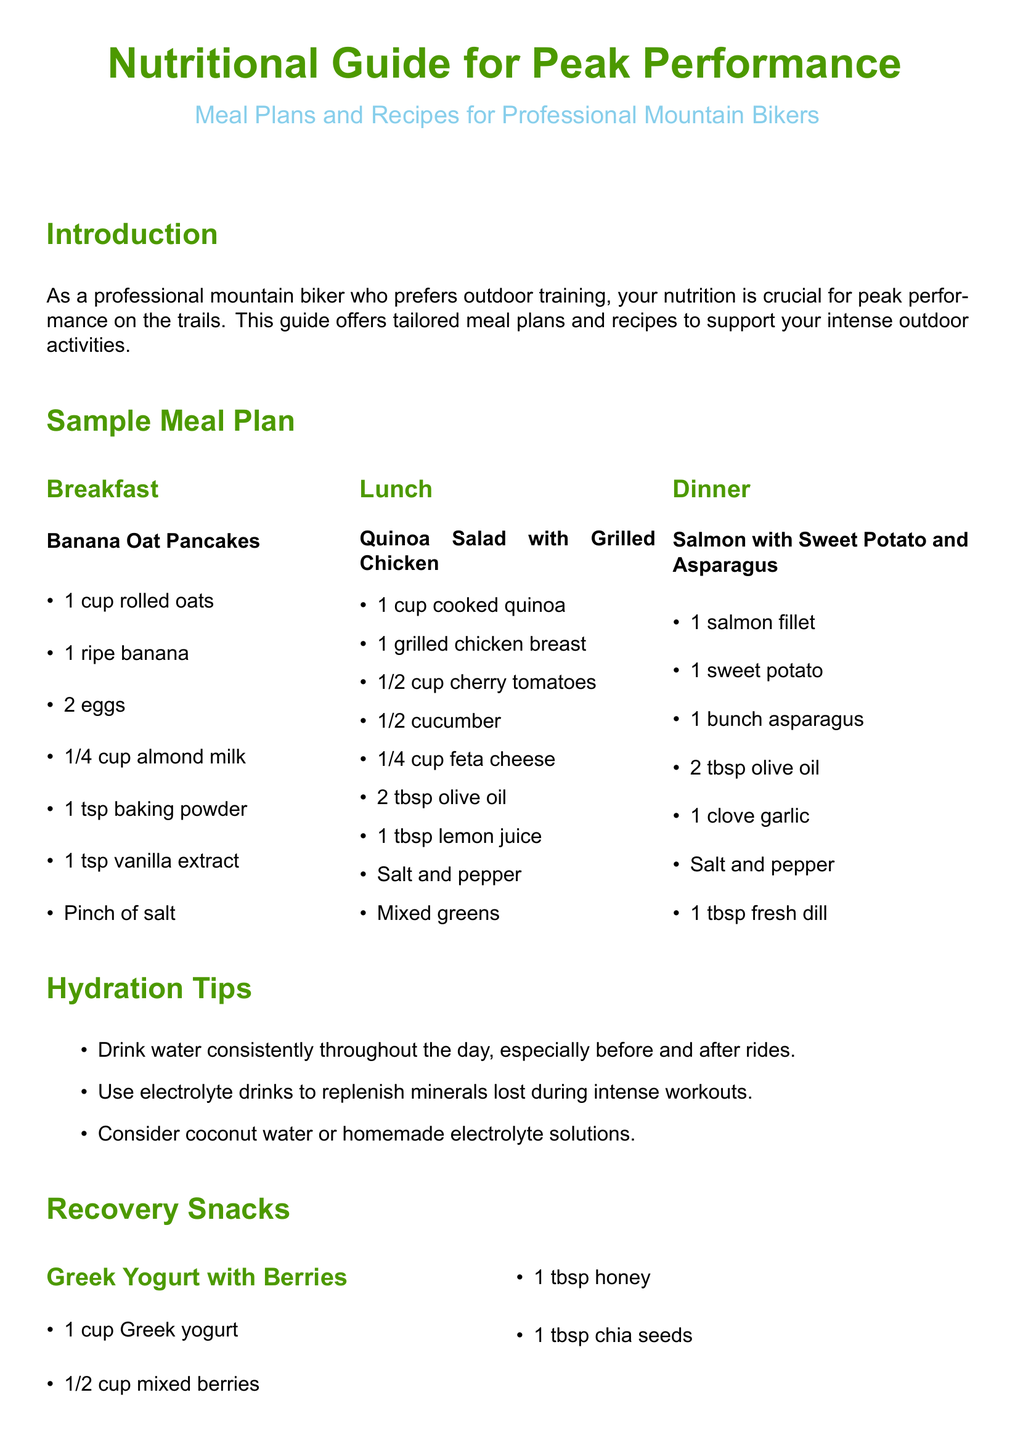What is the title of the document? The title is prominently displayed at the top of the document, indicating the main subject matter.
Answer: Nutritional Guide for Peak Performance How many meal plans are presented? The document lists three meal plans: breakfast, lunch, and dinner.
Answer: 3 What is one of the breakfast recipes mentioned? The document includes a specific breakfast recipe under the sample meal plan section.
Answer: Banana Oat Pancakes Which vegetable is listed in the dinner recipe? The dinner recipe includes asparagus, which is part of the ingredients.
Answer: Asparagus What type of drink is recommended for hydration? The hydration tips section suggests a specific category of beverages important for hydration during activities.
Answer: Electrolyte drinks What ingredient is used in the recovery snack "Greek Yogurt with Berries"? The recovery snack section specifies the use of Greek yogurt alongside other ingredients.
Answer: Greek Yogurt How much almond butter is used in the Almond Butter Banana Toast? The snack recipe details a precise amount of this ingredient in the preparation.
Answer: 1 tbsp What is stressed as crucial for professional mountain bikers' performance? The conclusion emphasizes a particular aspect of wellbeing vital for athletes in the sport.
Answer: Proper nutrition 